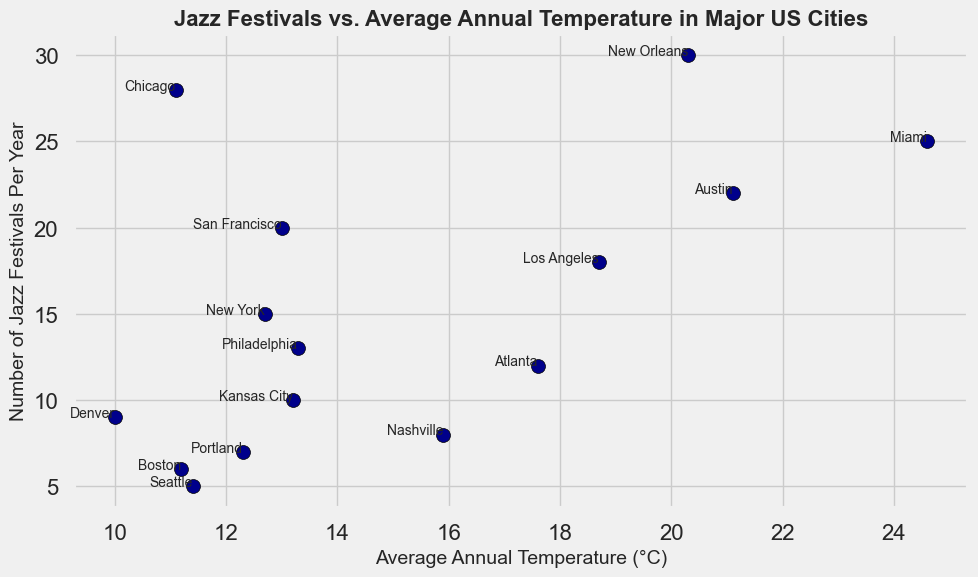Which city has the highest average annual temperature? The plot shows that Miami has the highest average annual temperature among the plotted cities.
Answer: Miami What is the difference in the number of jazz festivals between New Orleans and Seattle? New Orleans hosts 30 jazz festivals annually, while Seattle hosts 5. The difference is 30 - 5 = 25.
Answer: 25 Among the cities with temperatures above 20°C, which one has the lowest number of jazz festivals? The cities with temperatures above 20°C are New Orleans, Austin, and Miami. New Orleans has 30 festivals, Austin has 22, and Miami has 25. Therefore, Austin has the lowest number of jazz festivals among them.
Answer: Austin How many more jazz festivals does Chicago hold compared to Denver? Chicago holds 28 jazz festivals per year, while Denver holds 9. The difference is 28 - 9 = 19.
Answer: 19 Which city with an average annual temperature below 12°C has the most jazz festivals? Among the cities with temperatures below 12°C, the ones included are Chicago, Seattle, Boston, and Denver. Chicago has 28 festivals, which is the highest among these cities.
Answer: Chicago What is the average number of jazz festivals held annually by the cities with temperatures between 15°C and 18°C inclusive? The cities within this temperature range are Nashville (8), Philadelphia (13), Atlanta (12). The average is (8 + 13 + 12) / 3 = 11.
Answer: 11 Which cities have an average annual temperature exactly over 15°C? The cities with temperatures over 15°C are New Orleans, Los Angeles, Austin, Nashville, Atlanta, and Miami.
Answer: New Orleans, Los Angeles, Austin, Nashville, Atlanta, Miami Compare the number of jazz festivals in New York and San Francisco. Which city holds more, and by how many? New York holds 15 festivals, and San Francisco holds 20. San Francisco holds more jazz festivals than New York by 20 - 15 = 5.
Answer: San Francisco, 5 Which city with an average annual temperature of below 13°C has the second-most jazz festivals? The cities with temperatures below 13°C are Chicago (28), Boston (6), Seattle (5), Denver (9), and Portland (7). The second-most number of festivals is 9, hosted by Denver.
Answer: Denver How many cities listed have fewer than 10 jazz festivals annually? The cities with fewer than 10 festivals are Kansas City (10), Nashville (8), Seattle (5), Boston (6), Denver (9), and Portland (7). Thus, there are 5 such cities.
Answer: 5 